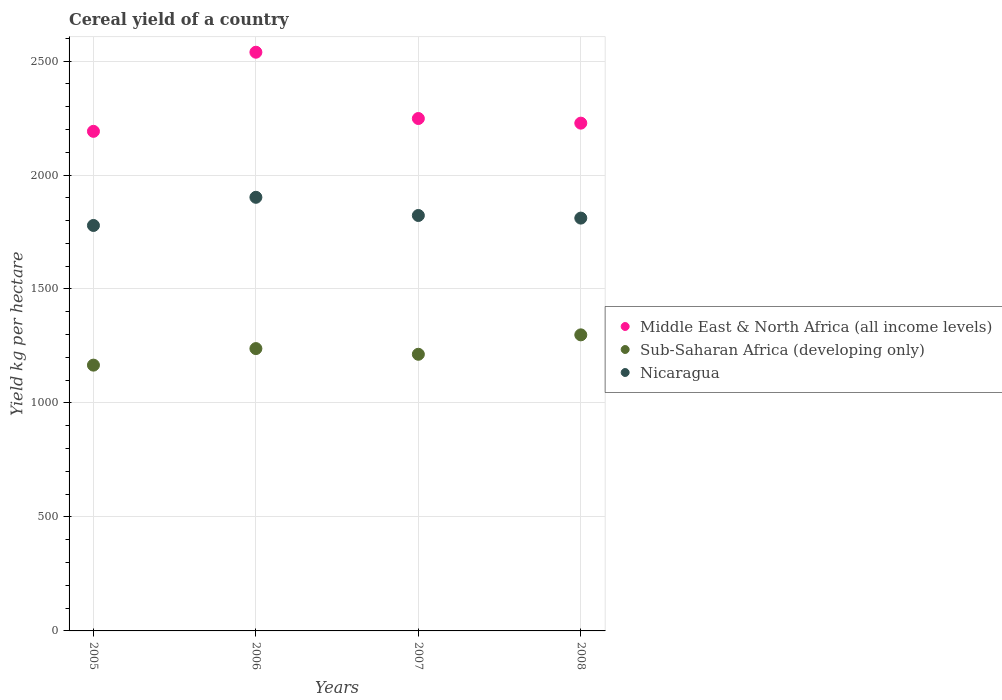What is the total cereal yield in Nicaragua in 2006?
Provide a succinct answer. 1902.26. Across all years, what is the maximum total cereal yield in Nicaragua?
Provide a succinct answer. 1902.26. Across all years, what is the minimum total cereal yield in Nicaragua?
Offer a very short reply. 1778.69. In which year was the total cereal yield in Sub-Saharan Africa (developing only) minimum?
Your response must be concise. 2005. What is the total total cereal yield in Middle East & North Africa (all income levels) in the graph?
Keep it short and to the point. 9205.75. What is the difference between the total cereal yield in Middle East & North Africa (all income levels) in 2005 and that in 2006?
Provide a succinct answer. -347.1. What is the difference between the total cereal yield in Nicaragua in 2005 and the total cereal yield in Sub-Saharan Africa (developing only) in 2007?
Ensure brevity in your answer.  565.09. What is the average total cereal yield in Nicaragua per year?
Ensure brevity in your answer.  1828.6. In the year 2008, what is the difference between the total cereal yield in Middle East & North Africa (all income levels) and total cereal yield in Sub-Saharan Africa (developing only)?
Your response must be concise. 928.73. In how many years, is the total cereal yield in Nicaragua greater than 600 kg per hectare?
Your answer should be very brief. 4. What is the ratio of the total cereal yield in Sub-Saharan Africa (developing only) in 2006 to that in 2007?
Your answer should be very brief. 1.02. What is the difference between the highest and the second highest total cereal yield in Nicaragua?
Provide a short and direct response. 79.79. What is the difference between the highest and the lowest total cereal yield in Sub-Saharan Africa (developing only)?
Provide a short and direct response. 132.82. Does the total cereal yield in Sub-Saharan Africa (developing only) monotonically increase over the years?
Offer a very short reply. No. Is the total cereal yield in Middle East & North Africa (all income levels) strictly less than the total cereal yield in Nicaragua over the years?
Give a very brief answer. No. How many dotlines are there?
Your answer should be compact. 3. How many years are there in the graph?
Provide a short and direct response. 4. What is the difference between two consecutive major ticks on the Y-axis?
Provide a short and direct response. 500. Does the graph contain any zero values?
Your answer should be very brief. No. Where does the legend appear in the graph?
Make the answer very short. Center right. How many legend labels are there?
Give a very brief answer. 3. How are the legend labels stacked?
Provide a succinct answer. Vertical. What is the title of the graph?
Keep it short and to the point. Cereal yield of a country. Does "Tajikistan" appear as one of the legend labels in the graph?
Your answer should be compact. No. What is the label or title of the Y-axis?
Your answer should be compact. Yield kg per hectare. What is the Yield kg per hectare of Middle East & North Africa (all income levels) in 2005?
Ensure brevity in your answer.  2191.61. What is the Yield kg per hectare in Sub-Saharan Africa (developing only) in 2005?
Your response must be concise. 1165.99. What is the Yield kg per hectare in Nicaragua in 2005?
Make the answer very short. 1778.69. What is the Yield kg per hectare in Middle East & North Africa (all income levels) in 2006?
Keep it short and to the point. 2538.71. What is the Yield kg per hectare of Sub-Saharan Africa (developing only) in 2006?
Offer a very short reply. 1238.59. What is the Yield kg per hectare of Nicaragua in 2006?
Keep it short and to the point. 1902.26. What is the Yield kg per hectare in Middle East & North Africa (all income levels) in 2007?
Offer a terse response. 2247.9. What is the Yield kg per hectare in Sub-Saharan Africa (developing only) in 2007?
Give a very brief answer. 1213.6. What is the Yield kg per hectare in Nicaragua in 2007?
Ensure brevity in your answer.  1822.47. What is the Yield kg per hectare in Middle East & North Africa (all income levels) in 2008?
Provide a short and direct response. 2227.54. What is the Yield kg per hectare in Sub-Saharan Africa (developing only) in 2008?
Keep it short and to the point. 1298.81. What is the Yield kg per hectare in Nicaragua in 2008?
Your answer should be very brief. 1811. Across all years, what is the maximum Yield kg per hectare of Middle East & North Africa (all income levels)?
Your answer should be compact. 2538.71. Across all years, what is the maximum Yield kg per hectare in Sub-Saharan Africa (developing only)?
Your answer should be very brief. 1298.81. Across all years, what is the maximum Yield kg per hectare of Nicaragua?
Offer a terse response. 1902.26. Across all years, what is the minimum Yield kg per hectare of Middle East & North Africa (all income levels)?
Your answer should be compact. 2191.61. Across all years, what is the minimum Yield kg per hectare of Sub-Saharan Africa (developing only)?
Provide a short and direct response. 1165.99. Across all years, what is the minimum Yield kg per hectare in Nicaragua?
Keep it short and to the point. 1778.69. What is the total Yield kg per hectare in Middle East & North Africa (all income levels) in the graph?
Ensure brevity in your answer.  9205.75. What is the total Yield kg per hectare of Sub-Saharan Africa (developing only) in the graph?
Keep it short and to the point. 4916.99. What is the total Yield kg per hectare of Nicaragua in the graph?
Provide a short and direct response. 7314.41. What is the difference between the Yield kg per hectare in Middle East & North Africa (all income levels) in 2005 and that in 2006?
Keep it short and to the point. -347.1. What is the difference between the Yield kg per hectare of Sub-Saharan Africa (developing only) in 2005 and that in 2006?
Offer a terse response. -72.61. What is the difference between the Yield kg per hectare of Nicaragua in 2005 and that in 2006?
Provide a succinct answer. -123.57. What is the difference between the Yield kg per hectare in Middle East & North Africa (all income levels) in 2005 and that in 2007?
Keep it short and to the point. -56.29. What is the difference between the Yield kg per hectare of Sub-Saharan Africa (developing only) in 2005 and that in 2007?
Your answer should be compact. -47.61. What is the difference between the Yield kg per hectare of Nicaragua in 2005 and that in 2007?
Provide a short and direct response. -43.78. What is the difference between the Yield kg per hectare in Middle East & North Africa (all income levels) in 2005 and that in 2008?
Offer a very short reply. -35.93. What is the difference between the Yield kg per hectare of Sub-Saharan Africa (developing only) in 2005 and that in 2008?
Your response must be concise. -132.82. What is the difference between the Yield kg per hectare in Nicaragua in 2005 and that in 2008?
Your response must be concise. -32.31. What is the difference between the Yield kg per hectare of Middle East & North Africa (all income levels) in 2006 and that in 2007?
Keep it short and to the point. 290.81. What is the difference between the Yield kg per hectare of Sub-Saharan Africa (developing only) in 2006 and that in 2007?
Keep it short and to the point. 25. What is the difference between the Yield kg per hectare in Nicaragua in 2006 and that in 2007?
Your answer should be compact. 79.79. What is the difference between the Yield kg per hectare in Middle East & North Africa (all income levels) in 2006 and that in 2008?
Provide a short and direct response. 311.17. What is the difference between the Yield kg per hectare of Sub-Saharan Africa (developing only) in 2006 and that in 2008?
Offer a terse response. -60.21. What is the difference between the Yield kg per hectare of Nicaragua in 2006 and that in 2008?
Give a very brief answer. 91.26. What is the difference between the Yield kg per hectare of Middle East & North Africa (all income levels) in 2007 and that in 2008?
Keep it short and to the point. 20.36. What is the difference between the Yield kg per hectare in Sub-Saharan Africa (developing only) in 2007 and that in 2008?
Provide a short and direct response. -85.21. What is the difference between the Yield kg per hectare of Nicaragua in 2007 and that in 2008?
Give a very brief answer. 11.47. What is the difference between the Yield kg per hectare in Middle East & North Africa (all income levels) in 2005 and the Yield kg per hectare in Sub-Saharan Africa (developing only) in 2006?
Offer a very short reply. 953.01. What is the difference between the Yield kg per hectare of Middle East & North Africa (all income levels) in 2005 and the Yield kg per hectare of Nicaragua in 2006?
Keep it short and to the point. 289.35. What is the difference between the Yield kg per hectare in Sub-Saharan Africa (developing only) in 2005 and the Yield kg per hectare in Nicaragua in 2006?
Give a very brief answer. -736.27. What is the difference between the Yield kg per hectare of Middle East & North Africa (all income levels) in 2005 and the Yield kg per hectare of Sub-Saharan Africa (developing only) in 2007?
Provide a short and direct response. 978.01. What is the difference between the Yield kg per hectare of Middle East & North Africa (all income levels) in 2005 and the Yield kg per hectare of Nicaragua in 2007?
Keep it short and to the point. 369.14. What is the difference between the Yield kg per hectare in Sub-Saharan Africa (developing only) in 2005 and the Yield kg per hectare in Nicaragua in 2007?
Offer a terse response. -656.48. What is the difference between the Yield kg per hectare in Middle East & North Africa (all income levels) in 2005 and the Yield kg per hectare in Sub-Saharan Africa (developing only) in 2008?
Your response must be concise. 892.8. What is the difference between the Yield kg per hectare of Middle East & North Africa (all income levels) in 2005 and the Yield kg per hectare of Nicaragua in 2008?
Provide a succinct answer. 380.61. What is the difference between the Yield kg per hectare of Sub-Saharan Africa (developing only) in 2005 and the Yield kg per hectare of Nicaragua in 2008?
Offer a terse response. -645.01. What is the difference between the Yield kg per hectare in Middle East & North Africa (all income levels) in 2006 and the Yield kg per hectare in Sub-Saharan Africa (developing only) in 2007?
Your response must be concise. 1325.11. What is the difference between the Yield kg per hectare of Middle East & North Africa (all income levels) in 2006 and the Yield kg per hectare of Nicaragua in 2007?
Keep it short and to the point. 716.24. What is the difference between the Yield kg per hectare in Sub-Saharan Africa (developing only) in 2006 and the Yield kg per hectare in Nicaragua in 2007?
Ensure brevity in your answer.  -583.87. What is the difference between the Yield kg per hectare of Middle East & North Africa (all income levels) in 2006 and the Yield kg per hectare of Sub-Saharan Africa (developing only) in 2008?
Make the answer very short. 1239.9. What is the difference between the Yield kg per hectare of Middle East & North Africa (all income levels) in 2006 and the Yield kg per hectare of Nicaragua in 2008?
Your response must be concise. 727.71. What is the difference between the Yield kg per hectare of Sub-Saharan Africa (developing only) in 2006 and the Yield kg per hectare of Nicaragua in 2008?
Your answer should be very brief. -572.41. What is the difference between the Yield kg per hectare in Middle East & North Africa (all income levels) in 2007 and the Yield kg per hectare in Sub-Saharan Africa (developing only) in 2008?
Make the answer very short. 949.09. What is the difference between the Yield kg per hectare in Middle East & North Africa (all income levels) in 2007 and the Yield kg per hectare in Nicaragua in 2008?
Your answer should be very brief. 436.9. What is the difference between the Yield kg per hectare of Sub-Saharan Africa (developing only) in 2007 and the Yield kg per hectare of Nicaragua in 2008?
Offer a very short reply. -597.4. What is the average Yield kg per hectare of Middle East & North Africa (all income levels) per year?
Offer a very short reply. 2301.44. What is the average Yield kg per hectare in Sub-Saharan Africa (developing only) per year?
Give a very brief answer. 1229.25. What is the average Yield kg per hectare of Nicaragua per year?
Keep it short and to the point. 1828.6. In the year 2005, what is the difference between the Yield kg per hectare in Middle East & North Africa (all income levels) and Yield kg per hectare in Sub-Saharan Africa (developing only)?
Keep it short and to the point. 1025.62. In the year 2005, what is the difference between the Yield kg per hectare in Middle East & North Africa (all income levels) and Yield kg per hectare in Nicaragua?
Make the answer very short. 412.92. In the year 2005, what is the difference between the Yield kg per hectare in Sub-Saharan Africa (developing only) and Yield kg per hectare in Nicaragua?
Provide a short and direct response. -612.7. In the year 2006, what is the difference between the Yield kg per hectare in Middle East & North Africa (all income levels) and Yield kg per hectare in Sub-Saharan Africa (developing only)?
Offer a terse response. 1300.12. In the year 2006, what is the difference between the Yield kg per hectare of Middle East & North Africa (all income levels) and Yield kg per hectare of Nicaragua?
Provide a succinct answer. 636.45. In the year 2006, what is the difference between the Yield kg per hectare in Sub-Saharan Africa (developing only) and Yield kg per hectare in Nicaragua?
Your answer should be compact. -663.66. In the year 2007, what is the difference between the Yield kg per hectare of Middle East & North Africa (all income levels) and Yield kg per hectare of Sub-Saharan Africa (developing only)?
Ensure brevity in your answer.  1034.3. In the year 2007, what is the difference between the Yield kg per hectare in Middle East & North Africa (all income levels) and Yield kg per hectare in Nicaragua?
Provide a succinct answer. 425.43. In the year 2007, what is the difference between the Yield kg per hectare in Sub-Saharan Africa (developing only) and Yield kg per hectare in Nicaragua?
Your answer should be compact. -608.87. In the year 2008, what is the difference between the Yield kg per hectare of Middle East & North Africa (all income levels) and Yield kg per hectare of Sub-Saharan Africa (developing only)?
Offer a terse response. 928.73. In the year 2008, what is the difference between the Yield kg per hectare of Middle East & North Africa (all income levels) and Yield kg per hectare of Nicaragua?
Provide a succinct answer. 416.54. In the year 2008, what is the difference between the Yield kg per hectare in Sub-Saharan Africa (developing only) and Yield kg per hectare in Nicaragua?
Offer a very short reply. -512.19. What is the ratio of the Yield kg per hectare of Middle East & North Africa (all income levels) in 2005 to that in 2006?
Your response must be concise. 0.86. What is the ratio of the Yield kg per hectare of Sub-Saharan Africa (developing only) in 2005 to that in 2006?
Your response must be concise. 0.94. What is the ratio of the Yield kg per hectare of Nicaragua in 2005 to that in 2006?
Your answer should be very brief. 0.94. What is the ratio of the Yield kg per hectare of Sub-Saharan Africa (developing only) in 2005 to that in 2007?
Give a very brief answer. 0.96. What is the ratio of the Yield kg per hectare of Middle East & North Africa (all income levels) in 2005 to that in 2008?
Offer a very short reply. 0.98. What is the ratio of the Yield kg per hectare in Sub-Saharan Africa (developing only) in 2005 to that in 2008?
Ensure brevity in your answer.  0.9. What is the ratio of the Yield kg per hectare in Nicaragua in 2005 to that in 2008?
Provide a short and direct response. 0.98. What is the ratio of the Yield kg per hectare of Middle East & North Africa (all income levels) in 2006 to that in 2007?
Provide a succinct answer. 1.13. What is the ratio of the Yield kg per hectare in Sub-Saharan Africa (developing only) in 2006 to that in 2007?
Give a very brief answer. 1.02. What is the ratio of the Yield kg per hectare in Nicaragua in 2006 to that in 2007?
Ensure brevity in your answer.  1.04. What is the ratio of the Yield kg per hectare of Middle East & North Africa (all income levels) in 2006 to that in 2008?
Give a very brief answer. 1.14. What is the ratio of the Yield kg per hectare in Sub-Saharan Africa (developing only) in 2006 to that in 2008?
Provide a short and direct response. 0.95. What is the ratio of the Yield kg per hectare in Nicaragua in 2006 to that in 2008?
Offer a terse response. 1.05. What is the ratio of the Yield kg per hectare in Middle East & North Africa (all income levels) in 2007 to that in 2008?
Provide a succinct answer. 1.01. What is the ratio of the Yield kg per hectare of Sub-Saharan Africa (developing only) in 2007 to that in 2008?
Give a very brief answer. 0.93. What is the difference between the highest and the second highest Yield kg per hectare in Middle East & North Africa (all income levels)?
Offer a very short reply. 290.81. What is the difference between the highest and the second highest Yield kg per hectare in Sub-Saharan Africa (developing only)?
Ensure brevity in your answer.  60.21. What is the difference between the highest and the second highest Yield kg per hectare of Nicaragua?
Your answer should be very brief. 79.79. What is the difference between the highest and the lowest Yield kg per hectare in Middle East & North Africa (all income levels)?
Offer a terse response. 347.1. What is the difference between the highest and the lowest Yield kg per hectare in Sub-Saharan Africa (developing only)?
Your answer should be very brief. 132.82. What is the difference between the highest and the lowest Yield kg per hectare of Nicaragua?
Your answer should be very brief. 123.57. 